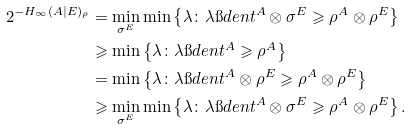<formula> <loc_0><loc_0><loc_500><loc_500>2 ^ { - H _ { \infty } ( A | E ) _ { \rho } } & = \min _ { \sigma ^ { E } } \min \left \{ \lambda \colon \lambda \i d e n t ^ { A } \otimes \sigma ^ { E } \geqslant \rho ^ { A } \otimes \rho ^ { E } \right \} \\ & \geqslant \min \left \{ \lambda \colon \lambda \i d e n t ^ { A } \geqslant \rho ^ { A } \right \} \\ & = \min \left \{ \lambda \colon \lambda \i d e n t ^ { A } \otimes \rho ^ { E } \geqslant \rho ^ { A } \otimes \rho ^ { E } \right \} \\ & \geqslant \min _ { \sigma ^ { E } } \min \left \{ \lambda \colon \lambda \i d e n t ^ { A } \otimes \sigma ^ { E } \geqslant \rho ^ { A } \otimes \rho ^ { E } \right \} .</formula> 